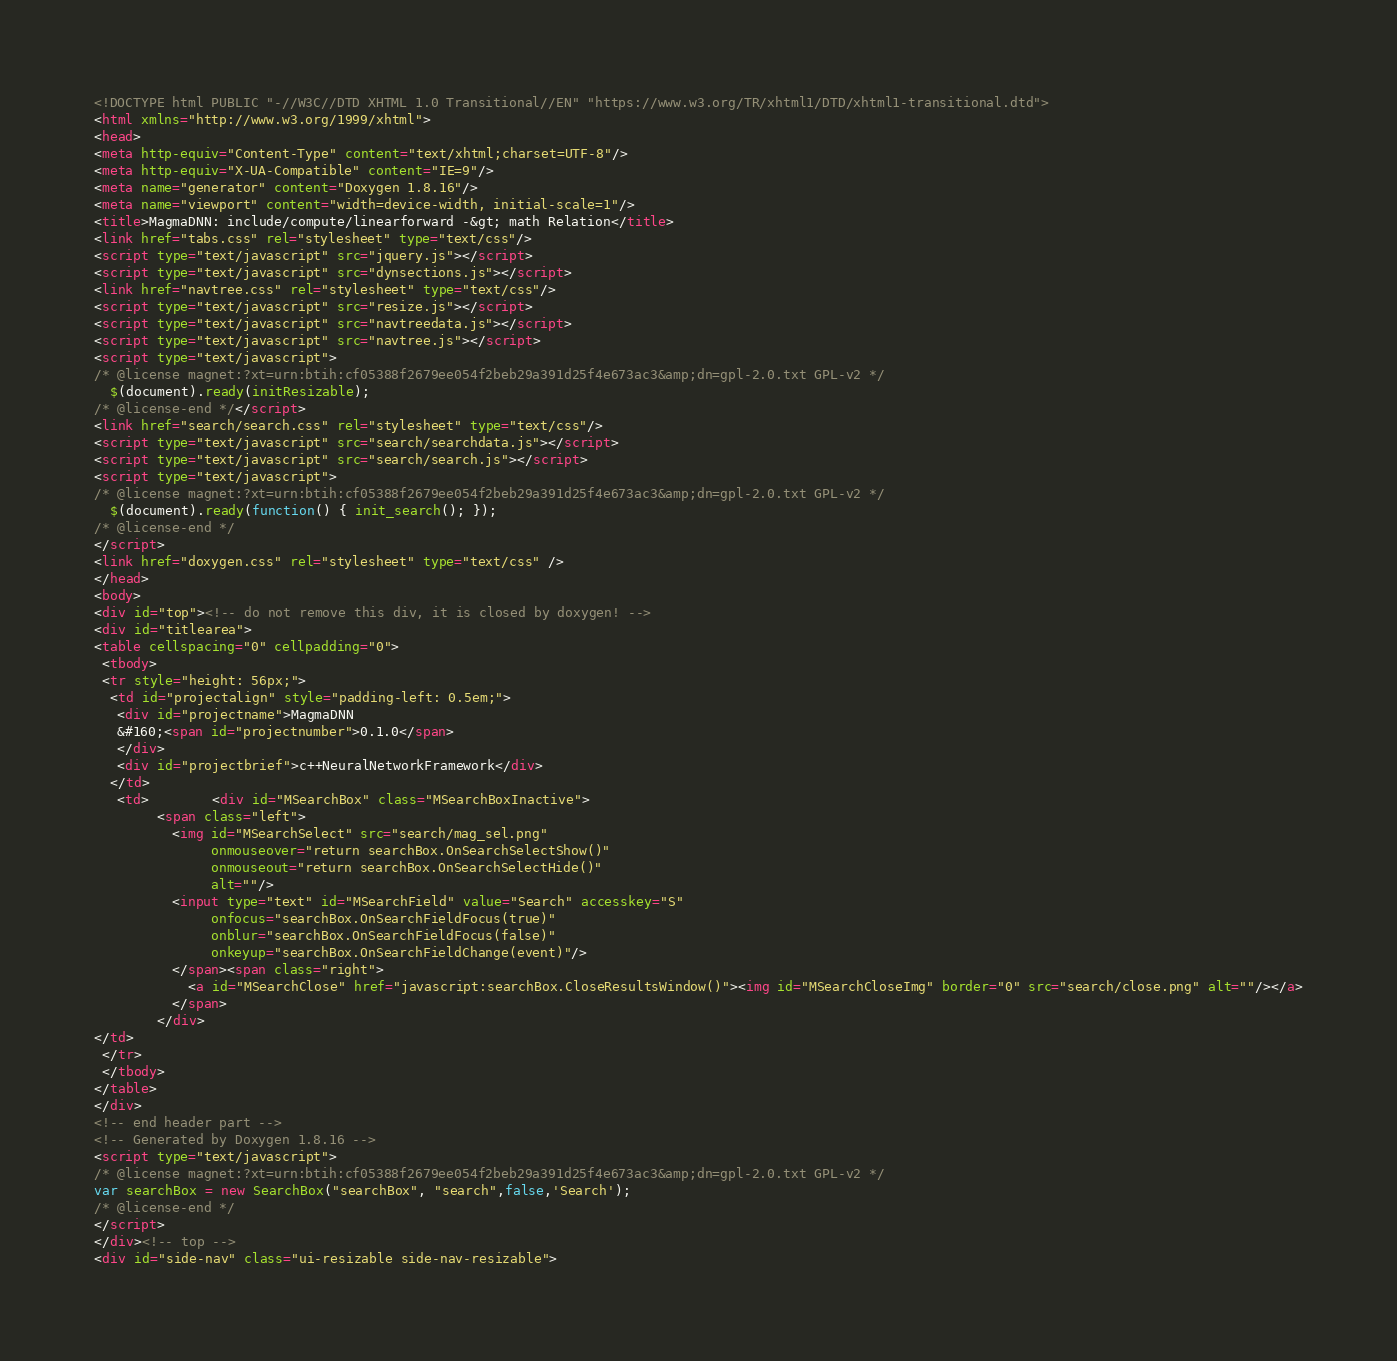<code> <loc_0><loc_0><loc_500><loc_500><_HTML_><!DOCTYPE html PUBLIC "-//W3C//DTD XHTML 1.0 Transitional//EN" "https://www.w3.org/TR/xhtml1/DTD/xhtml1-transitional.dtd">
<html xmlns="http://www.w3.org/1999/xhtml">
<head>
<meta http-equiv="Content-Type" content="text/xhtml;charset=UTF-8"/>
<meta http-equiv="X-UA-Compatible" content="IE=9"/>
<meta name="generator" content="Doxygen 1.8.16"/>
<meta name="viewport" content="width=device-width, initial-scale=1"/>
<title>MagmaDNN: include/compute/linearforward -&gt; math Relation</title>
<link href="tabs.css" rel="stylesheet" type="text/css"/>
<script type="text/javascript" src="jquery.js"></script>
<script type="text/javascript" src="dynsections.js"></script>
<link href="navtree.css" rel="stylesheet" type="text/css"/>
<script type="text/javascript" src="resize.js"></script>
<script type="text/javascript" src="navtreedata.js"></script>
<script type="text/javascript" src="navtree.js"></script>
<script type="text/javascript">
/* @license magnet:?xt=urn:btih:cf05388f2679ee054f2beb29a391d25f4e673ac3&amp;dn=gpl-2.0.txt GPL-v2 */
  $(document).ready(initResizable);
/* @license-end */</script>
<link href="search/search.css" rel="stylesheet" type="text/css"/>
<script type="text/javascript" src="search/searchdata.js"></script>
<script type="text/javascript" src="search/search.js"></script>
<script type="text/javascript">
/* @license magnet:?xt=urn:btih:cf05388f2679ee054f2beb29a391d25f4e673ac3&amp;dn=gpl-2.0.txt GPL-v2 */
  $(document).ready(function() { init_search(); });
/* @license-end */
</script>
<link href="doxygen.css" rel="stylesheet" type="text/css" />
</head>
<body>
<div id="top"><!-- do not remove this div, it is closed by doxygen! -->
<div id="titlearea">
<table cellspacing="0" cellpadding="0">
 <tbody>
 <tr style="height: 56px;">
  <td id="projectalign" style="padding-left: 0.5em;">
   <div id="projectname">MagmaDNN
   &#160;<span id="projectnumber">0.1.0</span>
   </div>
   <div id="projectbrief">c++NeuralNetworkFramework</div>
  </td>
   <td>        <div id="MSearchBox" class="MSearchBoxInactive">
        <span class="left">
          <img id="MSearchSelect" src="search/mag_sel.png"
               onmouseover="return searchBox.OnSearchSelectShow()"
               onmouseout="return searchBox.OnSearchSelectHide()"
               alt=""/>
          <input type="text" id="MSearchField" value="Search" accesskey="S"
               onfocus="searchBox.OnSearchFieldFocus(true)" 
               onblur="searchBox.OnSearchFieldFocus(false)" 
               onkeyup="searchBox.OnSearchFieldChange(event)"/>
          </span><span class="right">
            <a id="MSearchClose" href="javascript:searchBox.CloseResultsWindow()"><img id="MSearchCloseImg" border="0" src="search/close.png" alt=""/></a>
          </span>
        </div>
</td>
 </tr>
 </tbody>
</table>
</div>
<!-- end header part -->
<!-- Generated by Doxygen 1.8.16 -->
<script type="text/javascript">
/* @license magnet:?xt=urn:btih:cf05388f2679ee054f2beb29a391d25f4e673ac3&amp;dn=gpl-2.0.txt GPL-v2 */
var searchBox = new SearchBox("searchBox", "search",false,'Search');
/* @license-end */
</script>
</div><!-- top -->
<div id="side-nav" class="ui-resizable side-nav-resizable"></code> 